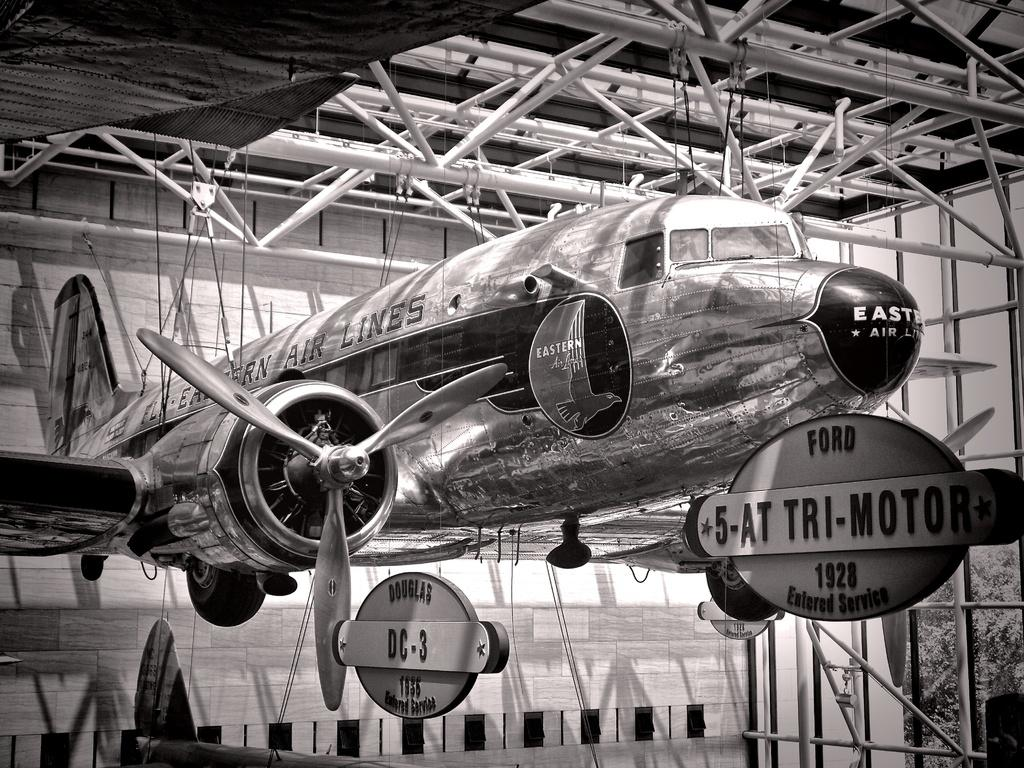What is the color scheme of the image? The image is black and white. What is the main subject of the image? There is an aircraft in the image. How is the aircraft positioned in the image? The aircraft is hanged from iron roads. What can be seen in the background of the image? There is a wall and boards with text in the background of the image. What type of nation is depicted on the mailbox in the image? There is no mailbox present in the image, so it is not possible to determine the depicted nation. Can you tell me how many gloves are visible in the image? There are no gloves present in the image. 